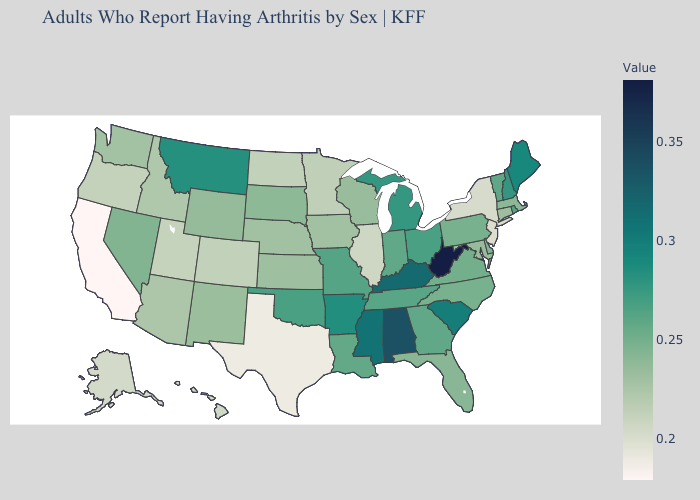Among the states that border Minnesota , which have the lowest value?
Write a very short answer. North Dakota. Does South Carolina have a lower value than Ohio?
Write a very short answer. No. Does Vermont have the highest value in the Northeast?
Keep it brief. No. Does New Mexico have the lowest value in the USA?
Quick response, please. No. 